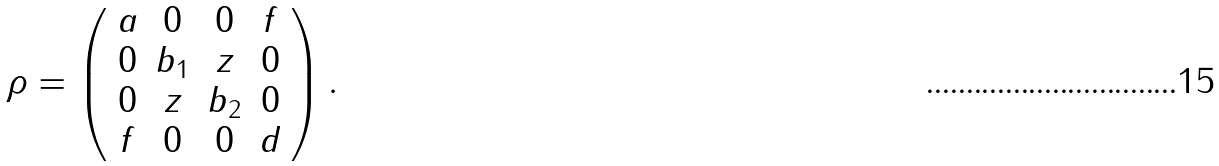<formula> <loc_0><loc_0><loc_500><loc_500>\mathcal { \rho } = \left ( \begin{array} { c c c c } a & 0 & 0 & f \\ 0 & b _ { 1 } & z & 0 \\ 0 & z & b _ { 2 } & 0 \\ f & 0 & 0 & d \end{array} \right ) .</formula> 